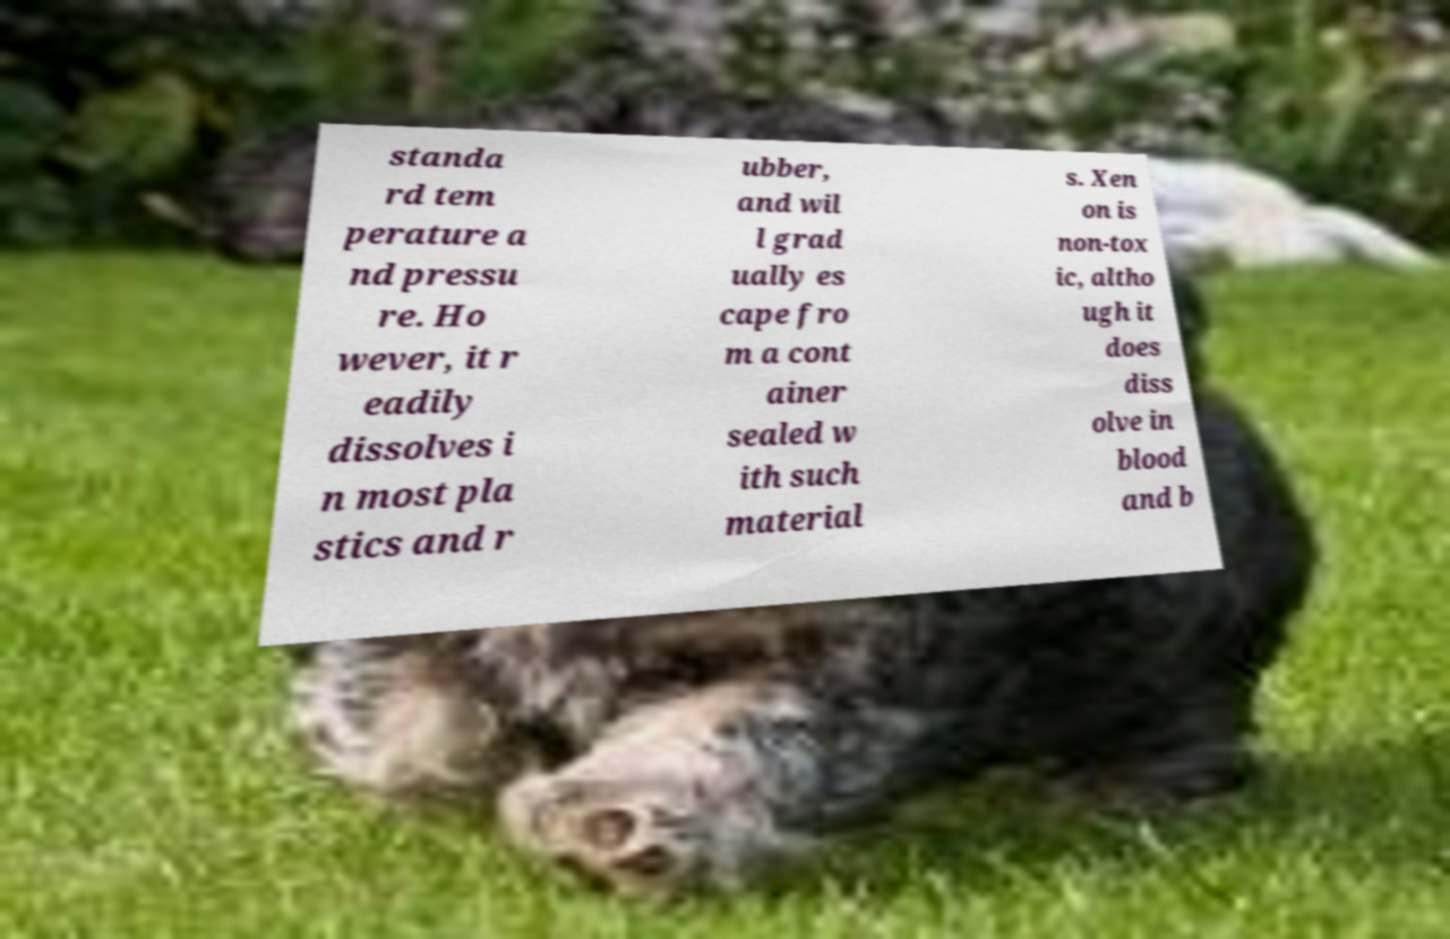Can you accurately transcribe the text from the provided image for me? standa rd tem perature a nd pressu re. Ho wever, it r eadily dissolves i n most pla stics and r ubber, and wil l grad ually es cape fro m a cont ainer sealed w ith such material s. Xen on is non-tox ic, altho ugh it does diss olve in blood and b 